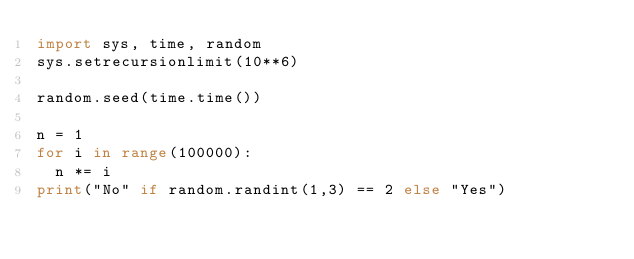Convert code to text. <code><loc_0><loc_0><loc_500><loc_500><_Python_>import sys, time, random
sys.setrecursionlimit(10**6)

random.seed(time.time())

n = 1
for i in range(100000):
	n *= i
print("No" if random.randint(1,3) == 2 else "Yes")
</code> 